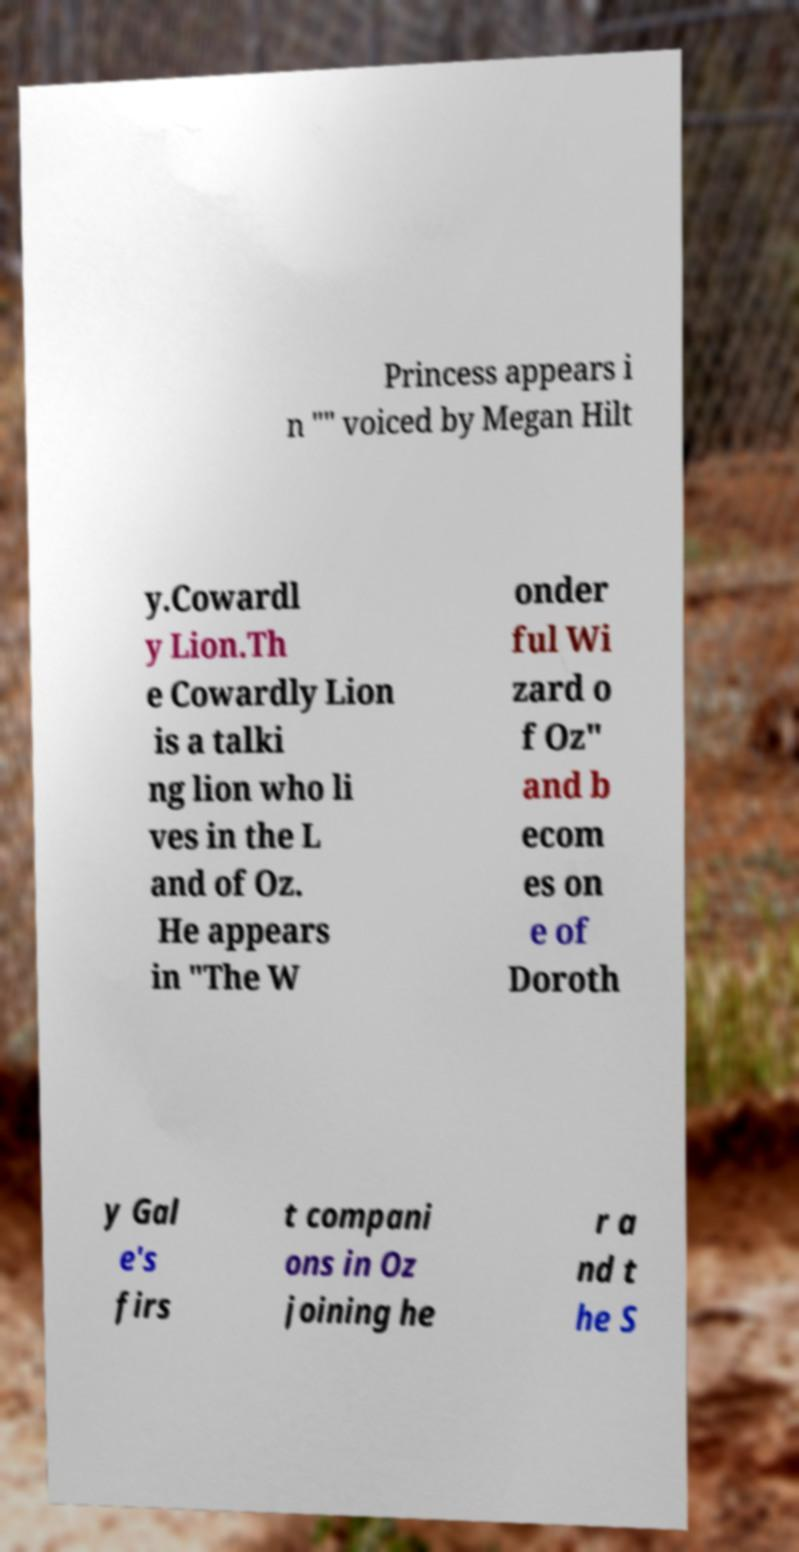For documentation purposes, I need the text within this image transcribed. Could you provide that? Princess appears i n "" voiced by Megan Hilt y.Cowardl y Lion.Th e Cowardly Lion is a talki ng lion who li ves in the L and of Oz. He appears in "The W onder ful Wi zard o f Oz" and b ecom es on e of Doroth y Gal e's firs t compani ons in Oz joining he r a nd t he S 